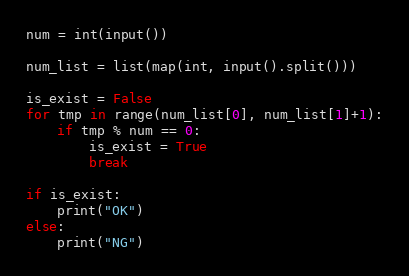<code> <loc_0><loc_0><loc_500><loc_500><_Python_>num = int(input())

num_list = list(map(int, input().split()))

is_exist = False
for tmp in range(num_list[0], num_list[1]+1):
    if tmp % num == 0:
        is_exist = True
        break

if is_exist:
    print("OK")
else:
    print("NG")
</code> 